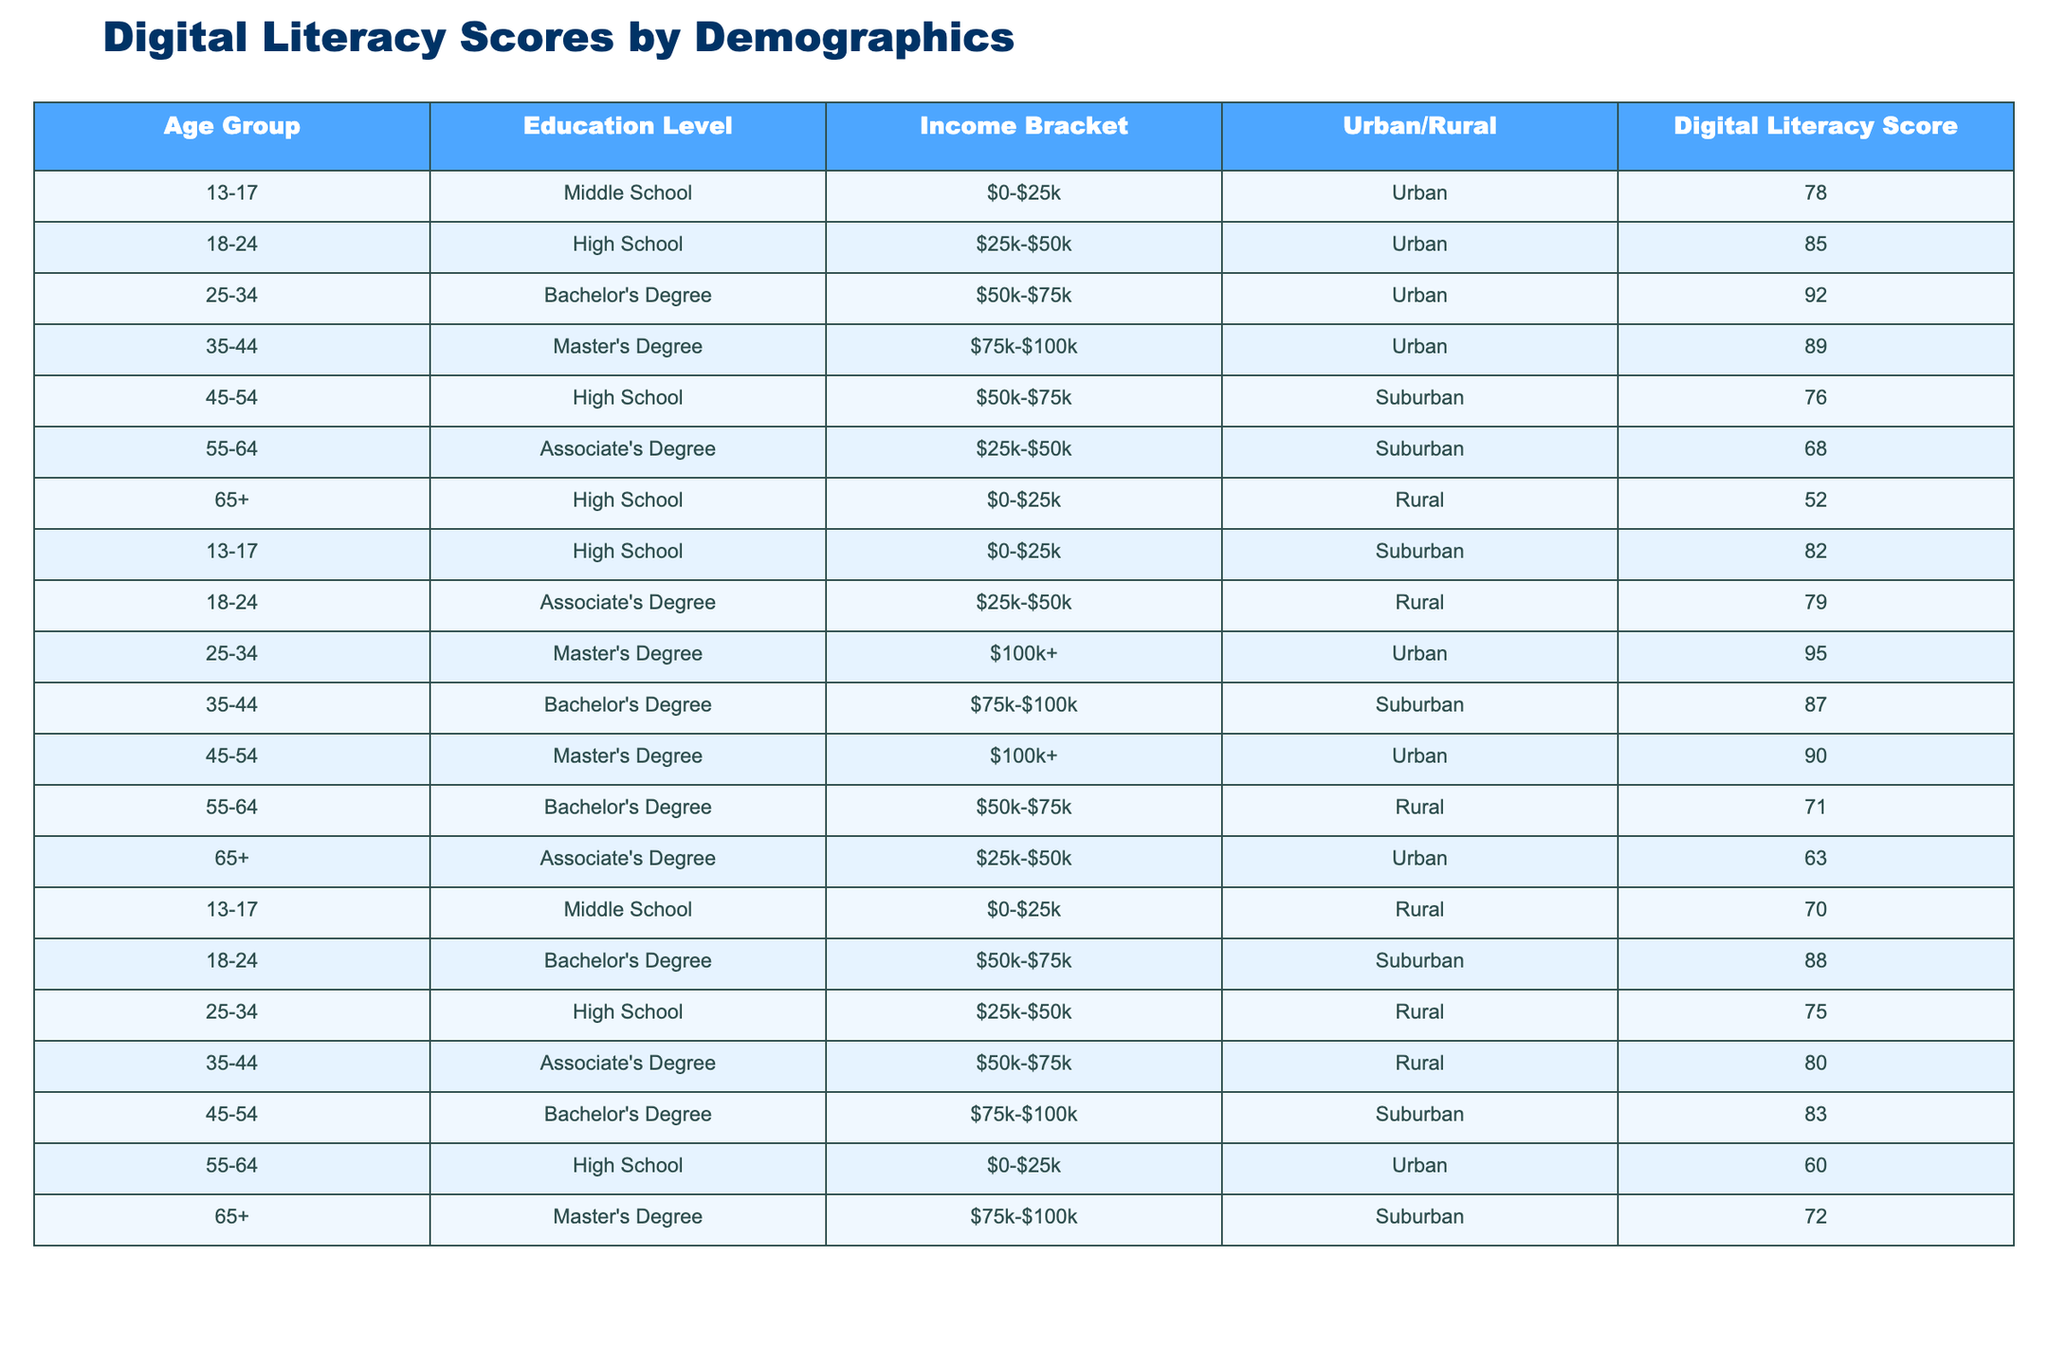What is the digital literacy score for the age group 35-44 with a Master's Degree? In the table, locate the row where the age group is 35-44 and the education level is Master's Degree. The digital literacy score in that row is 89.
Answer: 89 What is the highest digital literacy score among individuals aged 65+? Scan through the rows corresponding to the age group 65+. The highest score found is 72 for those with a Master's Degree living in the Suburban area.
Answer: 72 What is the average digital literacy score for the age group 18-24? The scores for age group 18-24 are 85, 79, and 88. To find the average, sum these scores: 85 + 79 + 88 = 252, then divide by 3 (number of entries), resulting in an average score of 84.
Answer: 84 Is the digital literacy score for individuals aged 55-64 in the Urban area higher than those in the Rural area? For age group 55-64, the Urban area score is 60, and the Rural area score is 71. Since 60 < 71, the statement is false.
Answer: No What is the digital literacy score for the age group 25-34 with a Bachelor's Degree? Identify the row for age group 25-34 and Bachelor's Degree. The corresponding digital literacy score is 92.
Answer: 92 Which age group and education level combination has the lowest digital literacy score? Check all scores in the table. The lowest score is 52 for age group 65+ with a High School education in Rural area.
Answer: 52 What is the difference in digital literacy scores between the highest and lowest scores for the age group 45-54? The score for 45-54 with High School is 76, and with Master's Degree is 90. The difference is 90 - 76 = 14.
Answer: 14 Are there more individuals in the 13-17 age group with Middle School education in Urban than in Rural areas? There are two entries for 13-17 with Middle School: one Urban (score 78) and one Rural (score 70). Since there is one for each area, they are equal.
Answer: No What is the overall average digital literacy score across all age groups? First, sum all the scores from the table (78, 85, 92, 89, 76, 68, 52, 82, 79, 95, 87, 90, 71, 63, 70, 88, 75, 80, 83, 60, 72). The total sum is 1521. Then, divide by the number of entries, 21. The overall average is 1521/21 = 72.4286, which rounds to 72.43.
Answer: 72.43 What percentage of individuals aged 55-64 have a score above 65? There are four individuals aged 55-64 with the following scores: 68, 71, 60, and 63. Only the scores 68 and 71 are above 65. The percentage is (2/4) * 100 = 50%.
Answer: 50% What is the digital literacy score for the most educated age group? Locate the entries with the highest education level: Master's Degree. The age group 25-34 with a Master's (score 95) has the highest score among all age groups.
Answer: 95 